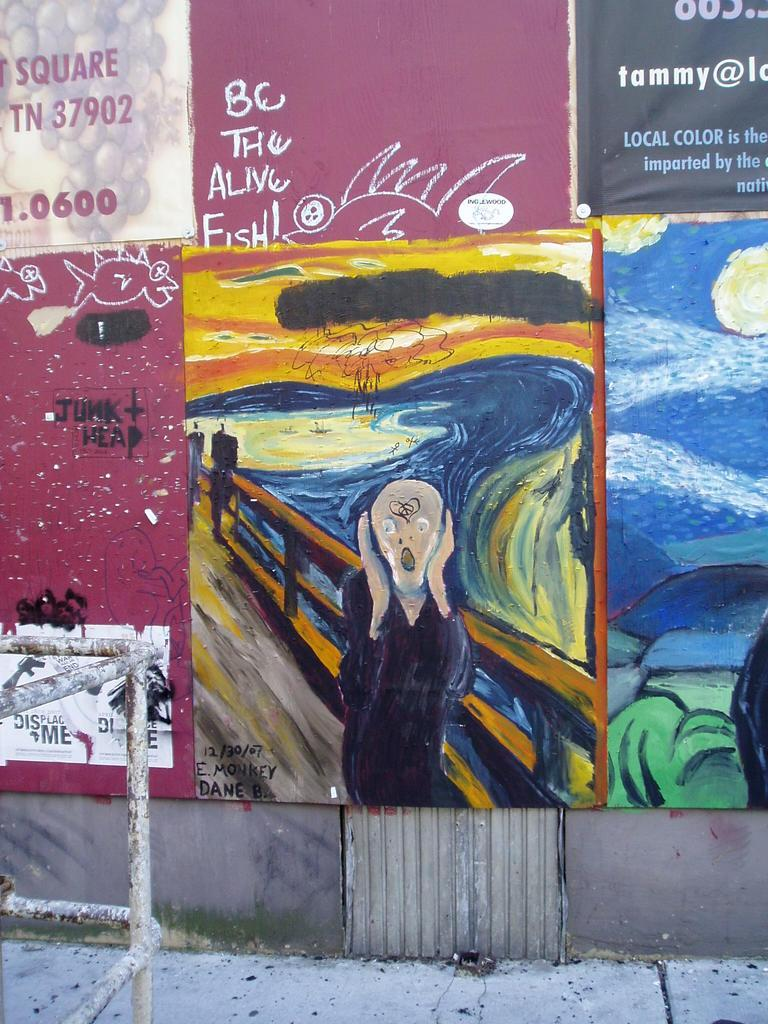What is displayed on the wall in the image? There are arts on the wall in the image. What type of material is used for the rods in the image? The rods in the image are made of metal. What type of fear can be seen in the eyes of the person in the image? There is no person present in the image, and therefore no eyes or fear to observe. 